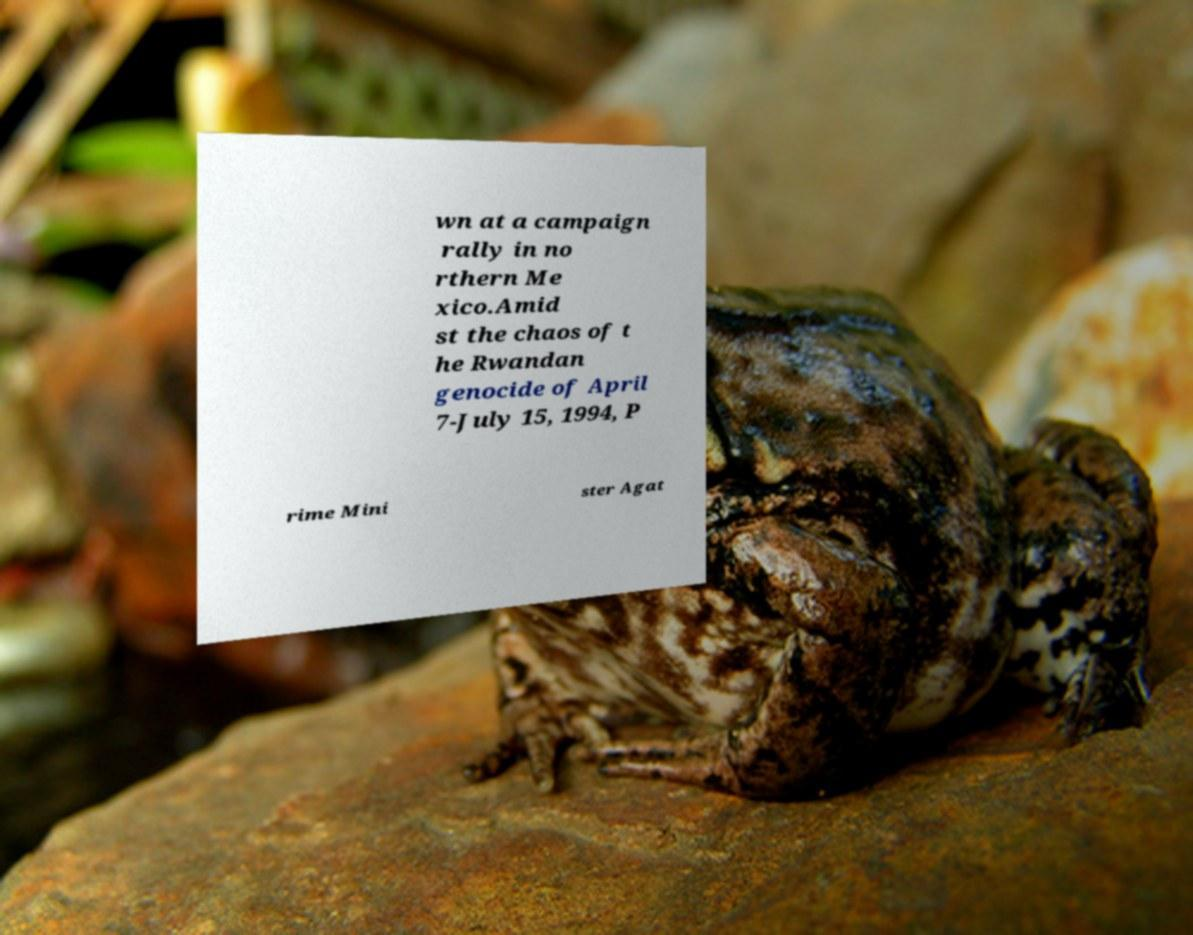Can you read and provide the text displayed in the image?This photo seems to have some interesting text. Can you extract and type it out for me? wn at a campaign rally in no rthern Me xico.Amid st the chaos of t he Rwandan genocide of April 7-July 15, 1994, P rime Mini ster Agat 